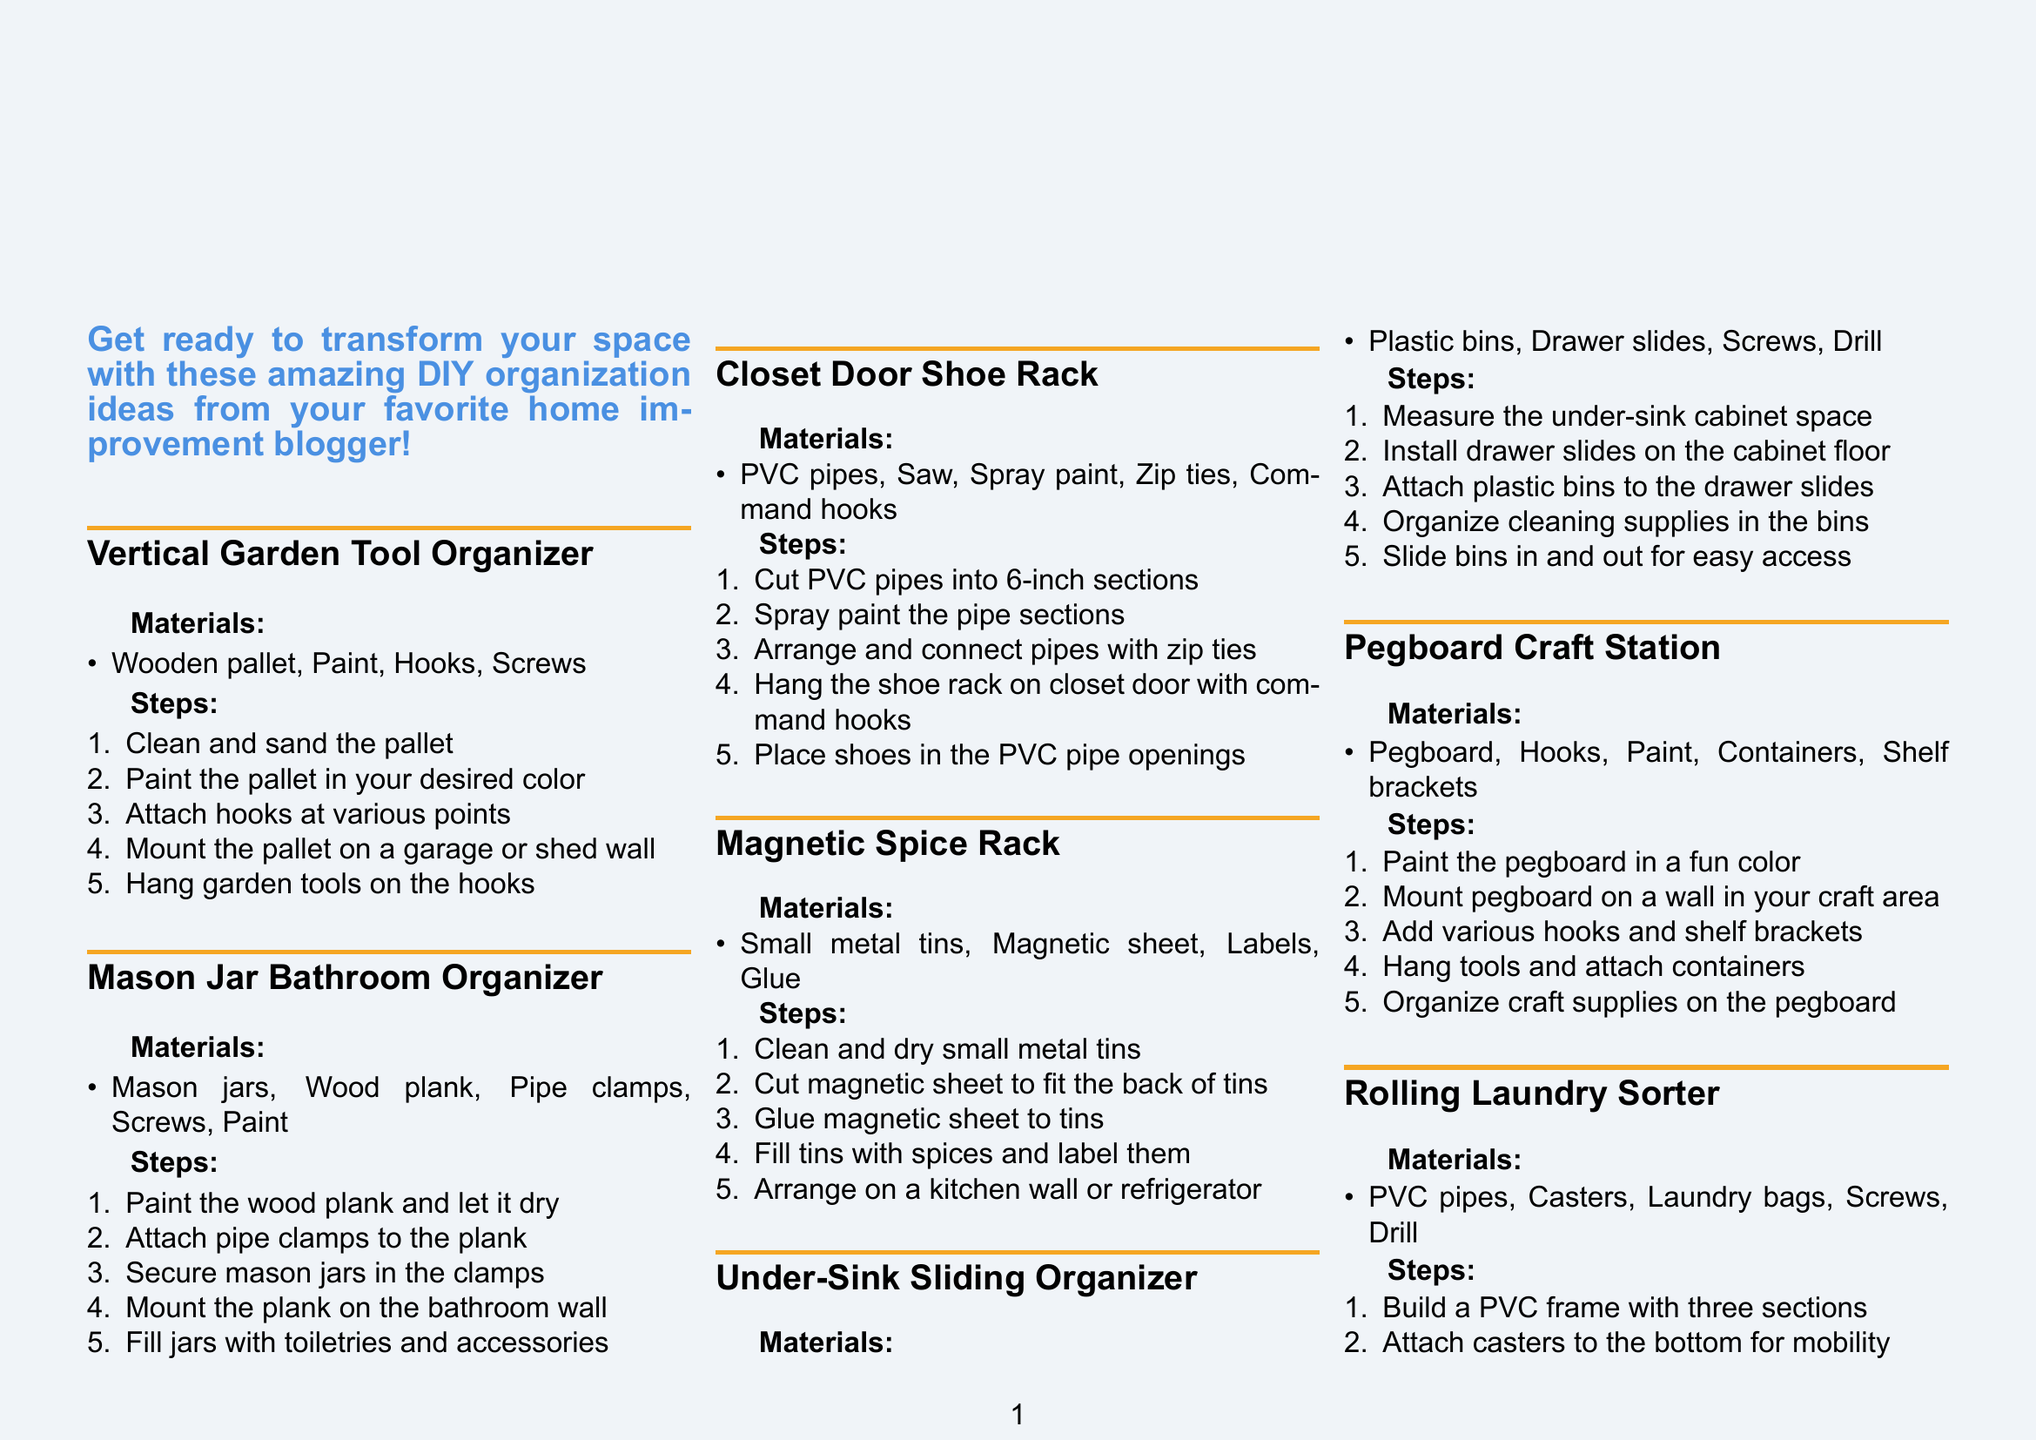What is the title of the brochure? The title is explicitly mentioned at the top of the document, which is "10 Genius DIY Home Organization Hacks."
Answer: 10 Genius DIY Home Organization Hacks How many DIY organization hacks are showcased? The brochure lists a total of 10 different DIY organization hacks in its content.
Answer: 10 What material is needed for the Mason Jar Bathroom Organizer? This information is gathered from the specific materials section for that hack, which includes Mason jars, Wood plank, Pipe clamps, Screws, and Paint.
Answer: Mason jars, Wood plank, Pipe clamps, Screws, Paint What is the final step for the Vertical Garden Tool Organizer? The last step listed under the instructions provides details on what to do after completing the earlier steps for this hack.
Answer: Hang garden tools on the hooks Which organization hack uses a tension rod? The hack that specifies the use of a tension rod is clearly stated among the listed hacks in the document.
Answer: Tension Rod Under-Sink Organizer What type of paint is suggested for the pegboard? The instructions for the Pegboard Craft Station indicate that users should choose a paint in a fun color for the pegboard.
Answer: Fun color Which before-and-after images are shown for the Under-Sink Sliding Organizer? The document identifies the images specifically tied to this hack, showing the transformation of the under-sink area before and after the organization.
Answer: messy_under_sink_area.jpg and organized_sliding_under_sink.jpg What should users do with their before-and-after photos? The conclusion of the brochure encourages users to share their transformation photos after completing the hacks.
Answer: Share your before-and-after photos Where can users find more detailed tutorials? The call to action in the document clearly directs readers to the blog for additional resources and inspiration regarding home improvement projects.
Answer: Visit our blog 